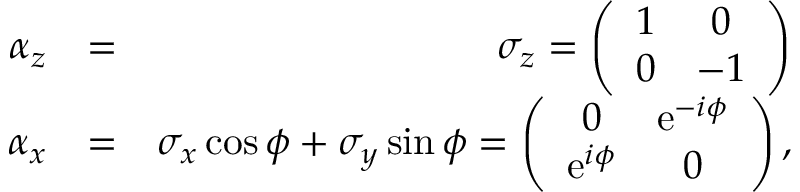<formula> <loc_0><loc_0><loc_500><loc_500>\begin{array} { r l r } { \alpha _ { z } } & { = } & { \sigma _ { z } = \left ( \begin{array} { c c } { 1 } & { 0 } \\ { 0 } & { - 1 } \end{array} \right ) } \\ { \alpha _ { x } } & { = } & { \sigma _ { x } \cos \phi + \sigma _ { y } \sin \phi = \left ( \begin{array} { c c } { 0 } & { e ^ { - i \phi } } \\ { e ^ { i \phi } } & { 0 } \end{array} \right ) , } \end{array}</formula> 